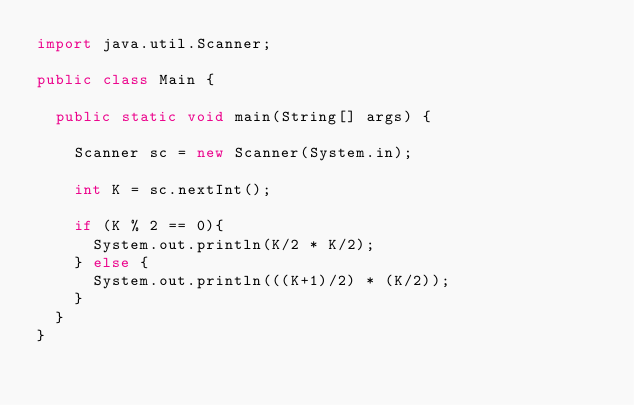<code> <loc_0><loc_0><loc_500><loc_500><_Java_>import java.util.Scanner;

public class Main {

	public static void main(String[] args) {

		Scanner sc = new Scanner(System.in);

		int K = sc.nextInt();

		if (K % 2 == 0){
			System.out.println(K/2 * K/2);
		} else {
			System.out.println(((K+1)/2) * (K/2));
		}
	}
}</code> 